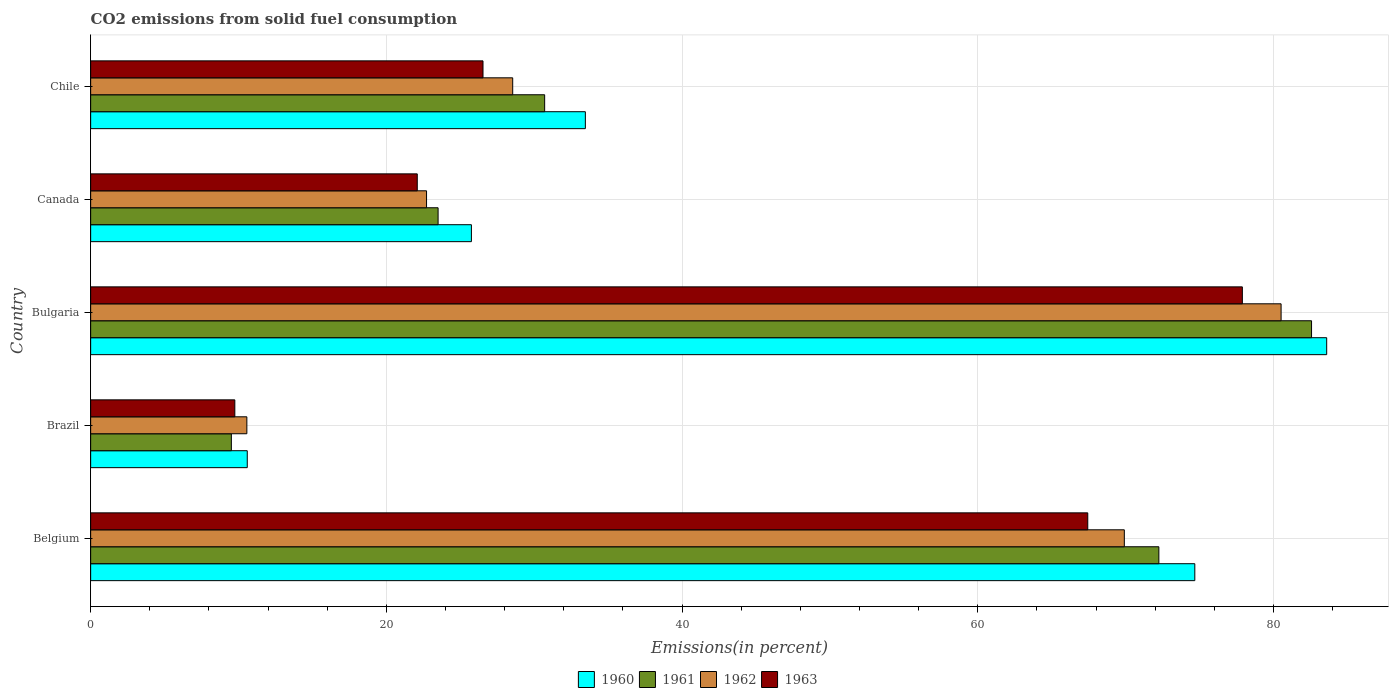How many groups of bars are there?
Your answer should be compact. 5. Are the number of bars per tick equal to the number of legend labels?
Your answer should be very brief. Yes. What is the label of the 1st group of bars from the top?
Your answer should be very brief. Chile. What is the total CO2 emitted in 1963 in Brazil?
Ensure brevity in your answer.  9.75. Across all countries, what is the maximum total CO2 emitted in 1962?
Make the answer very short. 80.52. Across all countries, what is the minimum total CO2 emitted in 1963?
Provide a short and direct response. 9.75. What is the total total CO2 emitted in 1962 in the graph?
Your response must be concise. 212.26. What is the difference between the total CO2 emitted in 1960 in Belgium and that in Chile?
Offer a terse response. 41.22. What is the difference between the total CO2 emitted in 1960 in Brazil and the total CO2 emitted in 1961 in Canada?
Keep it short and to the point. -12.91. What is the average total CO2 emitted in 1963 per country?
Your answer should be compact. 40.74. What is the difference between the total CO2 emitted in 1960 and total CO2 emitted in 1962 in Bulgaria?
Offer a terse response. 3.08. In how many countries, is the total CO2 emitted in 1962 greater than 8 %?
Provide a short and direct response. 5. What is the ratio of the total CO2 emitted in 1960 in Brazil to that in Bulgaria?
Offer a very short reply. 0.13. Is the total CO2 emitted in 1962 in Belgium less than that in Brazil?
Make the answer very short. No. Is the difference between the total CO2 emitted in 1960 in Belgium and Brazil greater than the difference between the total CO2 emitted in 1962 in Belgium and Brazil?
Provide a succinct answer. Yes. What is the difference between the highest and the second highest total CO2 emitted in 1963?
Offer a very short reply. 10.46. What is the difference between the highest and the lowest total CO2 emitted in 1963?
Ensure brevity in your answer.  68.15. In how many countries, is the total CO2 emitted in 1960 greater than the average total CO2 emitted in 1960 taken over all countries?
Provide a short and direct response. 2. Is the sum of the total CO2 emitted in 1960 in Brazil and Bulgaria greater than the maximum total CO2 emitted in 1961 across all countries?
Give a very brief answer. Yes. What does the 1st bar from the bottom in Brazil represents?
Offer a very short reply. 1960. Is it the case that in every country, the sum of the total CO2 emitted in 1960 and total CO2 emitted in 1963 is greater than the total CO2 emitted in 1961?
Make the answer very short. Yes. Are all the bars in the graph horizontal?
Ensure brevity in your answer.  Yes. How many countries are there in the graph?
Give a very brief answer. 5. Does the graph contain any zero values?
Provide a short and direct response. No. Does the graph contain grids?
Your answer should be compact. Yes. What is the title of the graph?
Your response must be concise. CO2 emissions from solid fuel consumption. What is the label or title of the X-axis?
Offer a very short reply. Emissions(in percent). What is the label or title of the Y-axis?
Make the answer very short. Country. What is the Emissions(in percent) in 1960 in Belgium?
Keep it short and to the point. 74.68. What is the Emissions(in percent) in 1961 in Belgium?
Give a very brief answer. 72.25. What is the Emissions(in percent) of 1962 in Belgium?
Make the answer very short. 69.91. What is the Emissions(in percent) in 1963 in Belgium?
Ensure brevity in your answer.  67.44. What is the Emissions(in percent) in 1960 in Brazil?
Your answer should be very brief. 10.59. What is the Emissions(in percent) in 1961 in Brazil?
Offer a very short reply. 9.52. What is the Emissions(in percent) of 1962 in Brazil?
Provide a short and direct response. 10.56. What is the Emissions(in percent) of 1963 in Brazil?
Give a very brief answer. 9.75. What is the Emissions(in percent) in 1960 in Bulgaria?
Make the answer very short. 83.6. What is the Emissions(in percent) in 1961 in Bulgaria?
Keep it short and to the point. 82.58. What is the Emissions(in percent) in 1962 in Bulgaria?
Provide a short and direct response. 80.52. What is the Emissions(in percent) of 1963 in Bulgaria?
Offer a very short reply. 77.9. What is the Emissions(in percent) in 1960 in Canada?
Your answer should be compact. 25.75. What is the Emissions(in percent) of 1961 in Canada?
Provide a succinct answer. 23.5. What is the Emissions(in percent) of 1962 in Canada?
Offer a terse response. 22.72. What is the Emissions(in percent) in 1963 in Canada?
Your answer should be very brief. 22.09. What is the Emissions(in percent) of 1960 in Chile?
Give a very brief answer. 33.46. What is the Emissions(in percent) in 1961 in Chile?
Provide a succinct answer. 30.71. What is the Emissions(in percent) in 1962 in Chile?
Provide a succinct answer. 28.55. What is the Emissions(in percent) in 1963 in Chile?
Your answer should be very brief. 26.54. Across all countries, what is the maximum Emissions(in percent) of 1960?
Provide a succinct answer. 83.6. Across all countries, what is the maximum Emissions(in percent) of 1961?
Your response must be concise. 82.58. Across all countries, what is the maximum Emissions(in percent) in 1962?
Offer a very short reply. 80.52. Across all countries, what is the maximum Emissions(in percent) in 1963?
Your response must be concise. 77.9. Across all countries, what is the minimum Emissions(in percent) in 1960?
Offer a very short reply. 10.59. Across all countries, what is the minimum Emissions(in percent) of 1961?
Give a very brief answer. 9.52. Across all countries, what is the minimum Emissions(in percent) in 1962?
Keep it short and to the point. 10.56. Across all countries, what is the minimum Emissions(in percent) in 1963?
Ensure brevity in your answer.  9.75. What is the total Emissions(in percent) in 1960 in the graph?
Your response must be concise. 228.09. What is the total Emissions(in percent) in 1961 in the graph?
Provide a short and direct response. 218.55. What is the total Emissions(in percent) of 1962 in the graph?
Give a very brief answer. 212.26. What is the total Emissions(in percent) in 1963 in the graph?
Ensure brevity in your answer.  203.72. What is the difference between the Emissions(in percent) in 1960 in Belgium and that in Brazil?
Your answer should be compact. 64.09. What is the difference between the Emissions(in percent) of 1961 in Belgium and that in Brazil?
Your answer should be compact. 62.73. What is the difference between the Emissions(in percent) in 1962 in Belgium and that in Brazil?
Offer a terse response. 59.35. What is the difference between the Emissions(in percent) in 1963 in Belgium and that in Brazil?
Offer a terse response. 57.69. What is the difference between the Emissions(in percent) in 1960 in Belgium and that in Bulgaria?
Your answer should be compact. -8.92. What is the difference between the Emissions(in percent) of 1961 in Belgium and that in Bulgaria?
Offer a terse response. -10.33. What is the difference between the Emissions(in percent) in 1962 in Belgium and that in Bulgaria?
Ensure brevity in your answer.  -10.6. What is the difference between the Emissions(in percent) in 1963 in Belgium and that in Bulgaria?
Offer a terse response. -10.46. What is the difference between the Emissions(in percent) of 1960 in Belgium and that in Canada?
Offer a terse response. 48.93. What is the difference between the Emissions(in percent) in 1961 in Belgium and that in Canada?
Make the answer very short. 48.75. What is the difference between the Emissions(in percent) in 1962 in Belgium and that in Canada?
Your answer should be very brief. 47.2. What is the difference between the Emissions(in percent) of 1963 in Belgium and that in Canada?
Your answer should be very brief. 45.35. What is the difference between the Emissions(in percent) in 1960 in Belgium and that in Chile?
Your response must be concise. 41.22. What is the difference between the Emissions(in percent) in 1961 in Belgium and that in Chile?
Offer a very short reply. 41.54. What is the difference between the Emissions(in percent) of 1962 in Belgium and that in Chile?
Make the answer very short. 41.37. What is the difference between the Emissions(in percent) in 1963 in Belgium and that in Chile?
Your answer should be very brief. 40.9. What is the difference between the Emissions(in percent) of 1960 in Brazil and that in Bulgaria?
Your answer should be very brief. -73.01. What is the difference between the Emissions(in percent) in 1961 in Brazil and that in Bulgaria?
Your answer should be compact. -73.06. What is the difference between the Emissions(in percent) in 1962 in Brazil and that in Bulgaria?
Offer a very short reply. -69.95. What is the difference between the Emissions(in percent) of 1963 in Brazil and that in Bulgaria?
Provide a short and direct response. -68.15. What is the difference between the Emissions(in percent) of 1960 in Brazil and that in Canada?
Your response must be concise. -15.16. What is the difference between the Emissions(in percent) in 1961 in Brazil and that in Canada?
Your answer should be compact. -13.98. What is the difference between the Emissions(in percent) in 1962 in Brazil and that in Canada?
Offer a very short reply. -12.15. What is the difference between the Emissions(in percent) of 1963 in Brazil and that in Canada?
Your response must be concise. -12.34. What is the difference between the Emissions(in percent) in 1960 in Brazil and that in Chile?
Make the answer very short. -22.87. What is the difference between the Emissions(in percent) in 1961 in Brazil and that in Chile?
Keep it short and to the point. -21.19. What is the difference between the Emissions(in percent) of 1962 in Brazil and that in Chile?
Keep it short and to the point. -17.98. What is the difference between the Emissions(in percent) of 1963 in Brazil and that in Chile?
Give a very brief answer. -16.79. What is the difference between the Emissions(in percent) of 1960 in Bulgaria and that in Canada?
Provide a succinct answer. 57.85. What is the difference between the Emissions(in percent) in 1961 in Bulgaria and that in Canada?
Provide a short and direct response. 59.08. What is the difference between the Emissions(in percent) of 1962 in Bulgaria and that in Canada?
Offer a very short reply. 57.8. What is the difference between the Emissions(in percent) in 1963 in Bulgaria and that in Canada?
Offer a terse response. 55.81. What is the difference between the Emissions(in percent) of 1960 in Bulgaria and that in Chile?
Your answer should be compact. 50.14. What is the difference between the Emissions(in percent) in 1961 in Bulgaria and that in Chile?
Your response must be concise. 51.87. What is the difference between the Emissions(in percent) of 1962 in Bulgaria and that in Chile?
Offer a very short reply. 51.97. What is the difference between the Emissions(in percent) in 1963 in Bulgaria and that in Chile?
Offer a very short reply. 51.36. What is the difference between the Emissions(in percent) in 1960 in Canada and that in Chile?
Offer a terse response. -7.71. What is the difference between the Emissions(in percent) of 1961 in Canada and that in Chile?
Provide a short and direct response. -7.21. What is the difference between the Emissions(in percent) in 1962 in Canada and that in Chile?
Keep it short and to the point. -5.83. What is the difference between the Emissions(in percent) in 1963 in Canada and that in Chile?
Offer a terse response. -4.45. What is the difference between the Emissions(in percent) of 1960 in Belgium and the Emissions(in percent) of 1961 in Brazil?
Your answer should be very brief. 65.16. What is the difference between the Emissions(in percent) in 1960 in Belgium and the Emissions(in percent) in 1962 in Brazil?
Make the answer very short. 64.12. What is the difference between the Emissions(in percent) in 1960 in Belgium and the Emissions(in percent) in 1963 in Brazil?
Your response must be concise. 64.93. What is the difference between the Emissions(in percent) of 1961 in Belgium and the Emissions(in percent) of 1962 in Brazil?
Offer a terse response. 61.69. What is the difference between the Emissions(in percent) of 1961 in Belgium and the Emissions(in percent) of 1963 in Brazil?
Keep it short and to the point. 62.5. What is the difference between the Emissions(in percent) in 1962 in Belgium and the Emissions(in percent) in 1963 in Brazil?
Provide a succinct answer. 60.16. What is the difference between the Emissions(in percent) in 1960 in Belgium and the Emissions(in percent) in 1961 in Bulgaria?
Ensure brevity in your answer.  -7.9. What is the difference between the Emissions(in percent) of 1960 in Belgium and the Emissions(in percent) of 1962 in Bulgaria?
Provide a succinct answer. -5.84. What is the difference between the Emissions(in percent) in 1960 in Belgium and the Emissions(in percent) in 1963 in Bulgaria?
Provide a succinct answer. -3.22. What is the difference between the Emissions(in percent) in 1961 in Belgium and the Emissions(in percent) in 1962 in Bulgaria?
Offer a terse response. -8.27. What is the difference between the Emissions(in percent) of 1961 in Belgium and the Emissions(in percent) of 1963 in Bulgaria?
Keep it short and to the point. -5.65. What is the difference between the Emissions(in percent) in 1962 in Belgium and the Emissions(in percent) in 1963 in Bulgaria?
Make the answer very short. -7.98. What is the difference between the Emissions(in percent) of 1960 in Belgium and the Emissions(in percent) of 1961 in Canada?
Your response must be concise. 51.18. What is the difference between the Emissions(in percent) in 1960 in Belgium and the Emissions(in percent) in 1962 in Canada?
Give a very brief answer. 51.96. What is the difference between the Emissions(in percent) of 1960 in Belgium and the Emissions(in percent) of 1963 in Canada?
Provide a short and direct response. 52.59. What is the difference between the Emissions(in percent) in 1961 in Belgium and the Emissions(in percent) in 1962 in Canada?
Keep it short and to the point. 49.53. What is the difference between the Emissions(in percent) of 1961 in Belgium and the Emissions(in percent) of 1963 in Canada?
Ensure brevity in your answer.  50.16. What is the difference between the Emissions(in percent) of 1962 in Belgium and the Emissions(in percent) of 1963 in Canada?
Provide a short and direct response. 47.82. What is the difference between the Emissions(in percent) in 1960 in Belgium and the Emissions(in percent) in 1961 in Chile?
Make the answer very short. 43.97. What is the difference between the Emissions(in percent) in 1960 in Belgium and the Emissions(in percent) in 1962 in Chile?
Provide a succinct answer. 46.14. What is the difference between the Emissions(in percent) in 1960 in Belgium and the Emissions(in percent) in 1963 in Chile?
Provide a short and direct response. 48.14. What is the difference between the Emissions(in percent) of 1961 in Belgium and the Emissions(in percent) of 1962 in Chile?
Ensure brevity in your answer.  43.7. What is the difference between the Emissions(in percent) of 1961 in Belgium and the Emissions(in percent) of 1963 in Chile?
Give a very brief answer. 45.71. What is the difference between the Emissions(in percent) of 1962 in Belgium and the Emissions(in percent) of 1963 in Chile?
Ensure brevity in your answer.  43.38. What is the difference between the Emissions(in percent) in 1960 in Brazil and the Emissions(in percent) in 1961 in Bulgaria?
Your response must be concise. -71.99. What is the difference between the Emissions(in percent) in 1960 in Brazil and the Emissions(in percent) in 1962 in Bulgaria?
Your answer should be compact. -69.93. What is the difference between the Emissions(in percent) in 1960 in Brazil and the Emissions(in percent) in 1963 in Bulgaria?
Your answer should be very brief. -67.31. What is the difference between the Emissions(in percent) of 1961 in Brazil and the Emissions(in percent) of 1962 in Bulgaria?
Your answer should be very brief. -71. What is the difference between the Emissions(in percent) in 1961 in Brazil and the Emissions(in percent) in 1963 in Bulgaria?
Your response must be concise. -68.38. What is the difference between the Emissions(in percent) of 1962 in Brazil and the Emissions(in percent) of 1963 in Bulgaria?
Give a very brief answer. -67.33. What is the difference between the Emissions(in percent) of 1960 in Brazil and the Emissions(in percent) of 1961 in Canada?
Provide a short and direct response. -12.91. What is the difference between the Emissions(in percent) in 1960 in Brazil and the Emissions(in percent) in 1962 in Canada?
Keep it short and to the point. -12.13. What is the difference between the Emissions(in percent) in 1960 in Brazil and the Emissions(in percent) in 1963 in Canada?
Provide a short and direct response. -11.5. What is the difference between the Emissions(in percent) of 1961 in Brazil and the Emissions(in percent) of 1962 in Canada?
Provide a short and direct response. -13.2. What is the difference between the Emissions(in percent) in 1961 in Brazil and the Emissions(in percent) in 1963 in Canada?
Provide a succinct answer. -12.57. What is the difference between the Emissions(in percent) in 1962 in Brazil and the Emissions(in percent) in 1963 in Canada?
Your answer should be compact. -11.53. What is the difference between the Emissions(in percent) in 1960 in Brazil and the Emissions(in percent) in 1961 in Chile?
Provide a succinct answer. -20.11. What is the difference between the Emissions(in percent) in 1960 in Brazil and the Emissions(in percent) in 1962 in Chile?
Provide a short and direct response. -17.95. What is the difference between the Emissions(in percent) in 1960 in Brazil and the Emissions(in percent) in 1963 in Chile?
Your answer should be very brief. -15.94. What is the difference between the Emissions(in percent) of 1961 in Brazil and the Emissions(in percent) of 1962 in Chile?
Ensure brevity in your answer.  -19.03. What is the difference between the Emissions(in percent) of 1961 in Brazil and the Emissions(in percent) of 1963 in Chile?
Ensure brevity in your answer.  -17.02. What is the difference between the Emissions(in percent) of 1962 in Brazil and the Emissions(in percent) of 1963 in Chile?
Your answer should be very brief. -15.97. What is the difference between the Emissions(in percent) of 1960 in Bulgaria and the Emissions(in percent) of 1961 in Canada?
Provide a succinct answer. 60.1. What is the difference between the Emissions(in percent) of 1960 in Bulgaria and the Emissions(in percent) of 1962 in Canada?
Offer a very short reply. 60.88. What is the difference between the Emissions(in percent) of 1960 in Bulgaria and the Emissions(in percent) of 1963 in Canada?
Offer a very short reply. 61.51. What is the difference between the Emissions(in percent) of 1961 in Bulgaria and the Emissions(in percent) of 1962 in Canada?
Your answer should be compact. 59.86. What is the difference between the Emissions(in percent) of 1961 in Bulgaria and the Emissions(in percent) of 1963 in Canada?
Keep it short and to the point. 60.49. What is the difference between the Emissions(in percent) in 1962 in Bulgaria and the Emissions(in percent) in 1963 in Canada?
Provide a succinct answer. 58.43. What is the difference between the Emissions(in percent) of 1960 in Bulgaria and the Emissions(in percent) of 1961 in Chile?
Your answer should be compact. 52.9. What is the difference between the Emissions(in percent) in 1960 in Bulgaria and the Emissions(in percent) in 1962 in Chile?
Offer a very short reply. 55.06. What is the difference between the Emissions(in percent) in 1960 in Bulgaria and the Emissions(in percent) in 1963 in Chile?
Give a very brief answer. 57.06. What is the difference between the Emissions(in percent) in 1961 in Bulgaria and the Emissions(in percent) in 1962 in Chile?
Your answer should be compact. 54.03. What is the difference between the Emissions(in percent) of 1961 in Bulgaria and the Emissions(in percent) of 1963 in Chile?
Offer a terse response. 56.04. What is the difference between the Emissions(in percent) of 1962 in Bulgaria and the Emissions(in percent) of 1963 in Chile?
Your answer should be compact. 53.98. What is the difference between the Emissions(in percent) in 1960 in Canada and the Emissions(in percent) in 1961 in Chile?
Offer a very short reply. -4.95. What is the difference between the Emissions(in percent) of 1960 in Canada and the Emissions(in percent) of 1962 in Chile?
Provide a short and direct response. -2.79. What is the difference between the Emissions(in percent) of 1960 in Canada and the Emissions(in percent) of 1963 in Chile?
Give a very brief answer. -0.78. What is the difference between the Emissions(in percent) of 1961 in Canada and the Emissions(in percent) of 1962 in Chile?
Your answer should be very brief. -5.05. What is the difference between the Emissions(in percent) in 1961 in Canada and the Emissions(in percent) in 1963 in Chile?
Offer a very short reply. -3.04. What is the difference between the Emissions(in percent) of 1962 in Canada and the Emissions(in percent) of 1963 in Chile?
Provide a short and direct response. -3.82. What is the average Emissions(in percent) of 1960 per country?
Offer a terse response. 45.62. What is the average Emissions(in percent) in 1961 per country?
Your answer should be compact. 43.71. What is the average Emissions(in percent) of 1962 per country?
Provide a succinct answer. 42.45. What is the average Emissions(in percent) in 1963 per country?
Give a very brief answer. 40.74. What is the difference between the Emissions(in percent) of 1960 and Emissions(in percent) of 1961 in Belgium?
Provide a short and direct response. 2.43. What is the difference between the Emissions(in percent) of 1960 and Emissions(in percent) of 1962 in Belgium?
Make the answer very short. 4.77. What is the difference between the Emissions(in percent) of 1960 and Emissions(in percent) of 1963 in Belgium?
Provide a succinct answer. 7.24. What is the difference between the Emissions(in percent) in 1961 and Emissions(in percent) in 1962 in Belgium?
Give a very brief answer. 2.34. What is the difference between the Emissions(in percent) of 1961 and Emissions(in percent) of 1963 in Belgium?
Your answer should be compact. 4.81. What is the difference between the Emissions(in percent) of 1962 and Emissions(in percent) of 1963 in Belgium?
Offer a very short reply. 2.47. What is the difference between the Emissions(in percent) of 1960 and Emissions(in percent) of 1961 in Brazil?
Give a very brief answer. 1.08. What is the difference between the Emissions(in percent) in 1960 and Emissions(in percent) in 1962 in Brazil?
Your answer should be very brief. 0.03. What is the difference between the Emissions(in percent) of 1960 and Emissions(in percent) of 1963 in Brazil?
Your response must be concise. 0.84. What is the difference between the Emissions(in percent) in 1961 and Emissions(in percent) in 1962 in Brazil?
Ensure brevity in your answer.  -1.05. What is the difference between the Emissions(in percent) of 1961 and Emissions(in percent) of 1963 in Brazil?
Give a very brief answer. -0.23. What is the difference between the Emissions(in percent) of 1962 and Emissions(in percent) of 1963 in Brazil?
Offer a terse response. 0.81. What is the difference between the Emissions(in percent) in 1960 and Emissions(in percent) in 1962 in Bulgaria?
Keep it short and to the point. 3.08. What is the difference between the Emissions(in percent) of 1960 and Emissions(in percent) of 1963 in Bulgaria?
Provide a succinct answer. 5.7. What is the difference between the Emissions(in percent) in 1961 and Emissions(in percent) in 1962 in Bulgaria?
Keep it short and to the point. 2.06. What is the difference between the Emissions(in percent) of 1961 and Emissions(in percent) of 1963 in Bulgaria?
Provide a succinct answer. 4.68. What is the difference between the Emissions(in percent) of 1962 and Emissions(in percent) of 1963 in Bulgaria?
Your response must be concise. 2.62. What is the difference between the Emissions(in percent) in 1960 and Emissions(in percent) in 1961 in Canada?
Give a very brief answer. 2.25. What is the difference between the Emissions(in percent) in 1960 and Emissions(in percent) in 1962 in Canada?
Offer a terse response. 3.03. What is the difference between the Emissions(in percent) of 1960 and Emissions(in percent) of 1963 in Canada?
Offer a terse response. 3.66. What is the difference between the Emissions(in percent) of 1961 and Emissions(in percent) of 1962 in Canada?
Provide a short and direct response. 0.78. What is the difference between the Emissions(in percent) of 1961 and Emissions(in percent) of 1963 in Canada?
Provide a short and direct response. 1.41. What is the difference between the Emissions(in percent) of 1962 and Emissions(in percent) of 1963 in Canada?
Give a very brief answer. 0.63. What is the difference between the Emissions(in percent) in 1960 and Emissions(in percent) in 1961 in Chile?
Ensure brevity in your answer.  2.75. What is the difference between the Emissions(in percent) of 1960 and Emissions(in percent) of 1962 in Chile?
Give a very brief answer. 4.91. What is the difference between the Emissions(in percent) of 1960 and Emissions(in percent) of 1963 in Chile?
Offer a very short reply. 6.92. What is the difference between the Emissions(in percent) of 1961 and Emissions(in percent) of 1962 in Chile?
Provide a succinct answer. 2.16. What is the difference between the Emissions(in percent) of 1961 and Emissions(in percent) of 1963 in Chile?
Give a very brief answer. 4.17. What is the difference between the Emissions(in percent) of 1962 and Emissions(in percent) of 1963 in Chile?
Your response must be concise. 2.01. What is the ratio of the Emissions(in percent) in 1960 in Belgium to that in Brazil?
Provide a short and direct response. 7.05. What is the ratio of the Emissions(in percent) in 1961 in Belgium to that in Brazil?
Offer a terse response. 7.59. What is the ratio of the Emissions(in percent) of 1962 in Belgium to that in Brazil?
Your answer should be very brief. 6.62. What is the ratio of the Emissions(in percent) of 1963 in Belgium to that in Brazil?
Your answer should be compact. 6.92. What is the ratio of the Emissions(in percent) in 1960 in Belgium to that in Bulgaria?
Ensure brevity in your answer.  0.89. What is the ratio of the Emissions(in percent) of 1961 in Belgium to that in Bulgaria?
Provide a succinct answer. 0.87. What is the ratio of the Emissions(in percent) of 1962 in Belgium to that in Bulgaria?
Keep it short and to the point. 0.87. What is the ratio of the Emissions(in percent) of 1963 in Belgium to that in Bulgaria?
Offer a very short reply. 0.87. What is the ratio of the Emissions(in percent) in 1960 in Belgium to that in Canada?
Make the answer very short. 2.9. What is the ratio of the Emissions(in percent) of 1961 in Belgium to that in Canada?
Offer a terse response. 3.07. What is the ratio of the Emissions(in percent) of 1962 in Belgium to that in Canada?
Offer a terse response. 3.08. What is the ratio of the Emissions(in percent) in 1963 in Belgium to that in Canada?
Your answer should be compact. 3.05. What is the ratio of the Emissions(in percent) of 1960 in Belgium to that in Chile?
Your answer should be very brief. 2.23. What is the ratio of the Emissions(in percent) in 1961 in Belgium to that in Chile?
Your response must be concise. 2.35. What is the ratio of the Emissions(in percent) of 1962 in Belgium to that in Chile?
Make the answer very short. 2.45. What is the ratio of the Emissions(in percent) in 1963 in Belgium to that in Chile?
Your answer should be very brief. 2.54. What is the ratio of the Emissions(in percent) of 1960 in Brazil to that in Bulgaria?
Make the answer very short. 0.13. What is the ratio of the Emissions(in percent) of 1961 in Brazil to that in Bulgaria?
Provide a short and direct response. 0.12. What is the ratio of the Emissions(in percent) of 1962 in Brazil to that in Bulgaria?
Offer a very short reply. 0.13. What is the ratio of the Emissions(in percent) in 1963 in Brazil to that in Bulgaria?
Provide a short and direct response. 0.13. What is the ratio of the Emissions(in percent) of 1960 in Brazil to that in Canada?
Offer a terse response. 0.41. What is the ratio of the Emissions(in percent) in 1961 in Brazil to that in Canada?
Offer a terse response. 0.41. What is the ratio of the Emissions(in percent) of 1962 in Brazil to that in Canada?
Your response must be concise. 0.47. What is the ratio of the Emissions(in percent) of 1963 in Brazil to that in Canada?
Offer a very short reply. 0.44. What is the ratio of the Emissions(in percent) of 1960 in Brazil to that in Chile?
Your response must be concise. 0.32. What is the ratio of the Emissions(in percent) in 1961 in Brazil to that in Chile?
Provide a short and direct response. 0.31. What is the ratio of the Emissions(in percent) of 1962 in Brazil to that in Chile?
Offer a terse response. 0.37. What is the ratio of the Emissions(in percent) of 1963 in Brazil to that in Chile?
Provide a succinct answer. 0.37. What is the ratio of the Emissions(in percent) in 1960 in Bulgaria to that in Canada?
Provide a short and direct response. 3.25. What is the ratio of the Emissions(in percent) of 1961 in Bulgaria to that in Canada?
Keep it short and to the point. 3.51. What is the ratio of the Emissions(in percent) of 1962 in Bulgaria to that in Canada?
Ensure brevity in your answer.  3.54. What is the ratio of the Emissions(in percent) in 1963 in Bulgaria to that in Canada?
Your response must be concise. 3.53. What is the ratio of the Emissions(in percent) in 1960 in Bulgaria to that in Chile?
Your response must be concise. 2.5. What is the ratio of the Emissions(in percent) in 1961 in Bulgaria to that in Chile?
Your response must be concise. 2.69. What is the ratio of the Emissions(in percent) in 1962 in Bulgaria to that in Chile?
Offer a very short reply. 2.82. What is the ratio of the Emissions(in percent) in 1963 in Bulgaria to that in Chile?
Keep it short and to the point. 2.94. What is the ratio of the Emissions(in percent) in 1960 in Canada to that in Chile?
Your answer should be very brief. 0.77. What is the ratio of the Emissions(in percent) of 1961 in Canada to that in Chile?
Provide a succinct answer. 0.77. What is the ratio of the Emissions(in percent) in 1962 in Canada to that in Chile?
Provide a succinct answer. 0.8. What is the ratio of the Emissions(in percent) in 1963 in Canada to that in Chile?
Offer a terse response. 0.83. What is the difference between the highest and the second highest Emissions(in percent) of 1960?
Ensure brevity in your answer.  8.92. What is the difference between the highest and the second highest Emissions(in percent) of 1961?
Offer a very short reply. 10.33. What is the difference between the highest and the second highest Emissions(in percent) in 1962?
Your response must be concise. 10.6. What is the difference between the highest and the second highest Emissions(in percent) in 1963?
Keep it short and to the point. 10.46. What is the difference between the highest and the lowest Emissions(in percent) in 1960?
Your answer should be very brief. 73.01. What is the difference between the highest and the lowest Emissions(in percent) in 1961?
Offer a terse response. 73.06. What is the difference between the highest and the lowest Emissions(in percent) of 1962?
Give a very brief answer. 69.95. What is the difference between the highest and the lowest Emissions(in percent) of 1963?
Ensure brevity in your answer.  68.15. 